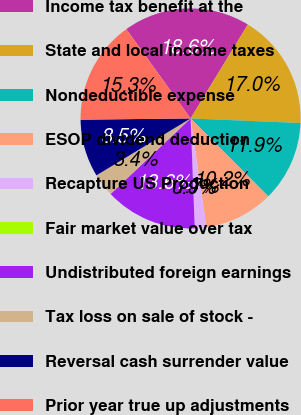Convert chart. <chart><loc_0><loc_0><loc_500><loc_500><pie_chart><fcel>Income tax benefit at the<fcel>State and local income taxes<fcel>Nondeductible expense<fcel>ESOP dividend deduction<fcel>Recapture US Production<fcel>Fair market value over tax<fcel>Undistributed foreign earnings<fcel>Tax loss on sale of stock -<fcel>Reversal cash surrender value<fcel>Prior year true up adjustments<nl><fcel>18.64%<fcel>16.95%<fcel>11.86%<fcel>10.17%<fcel>1.7%<fcel>0.0%<fcel>13.56%<fcel>3.39%<fcel>8.47%<fcel>15.25%<nl></chart> 